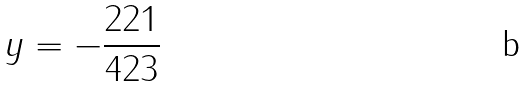Convert formula to latex. <formula><loc_0><loc_0><loc_500><loc_500>y = - \frac { 2 2 1 } { 4 2 3 }</formula> 